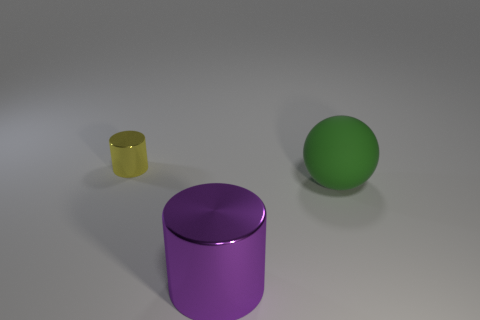Subtract all yellow cylinders. Subtract all purple spheres. How many cylinders are left? 1 Add 3 matte spheres. How many objects exist? 6 Subtract all cylinders. How many objects are left? 1 Subtract 0 brown spheres. How many objects are left? 3 Subtract all matte balls. Subtract all big rubber objects. How many objects are left? 1 Add 2 large green balls. How many large green balls are left? 3 Add 2 tiny cylinders. How many tiny cylinders exist? 3 